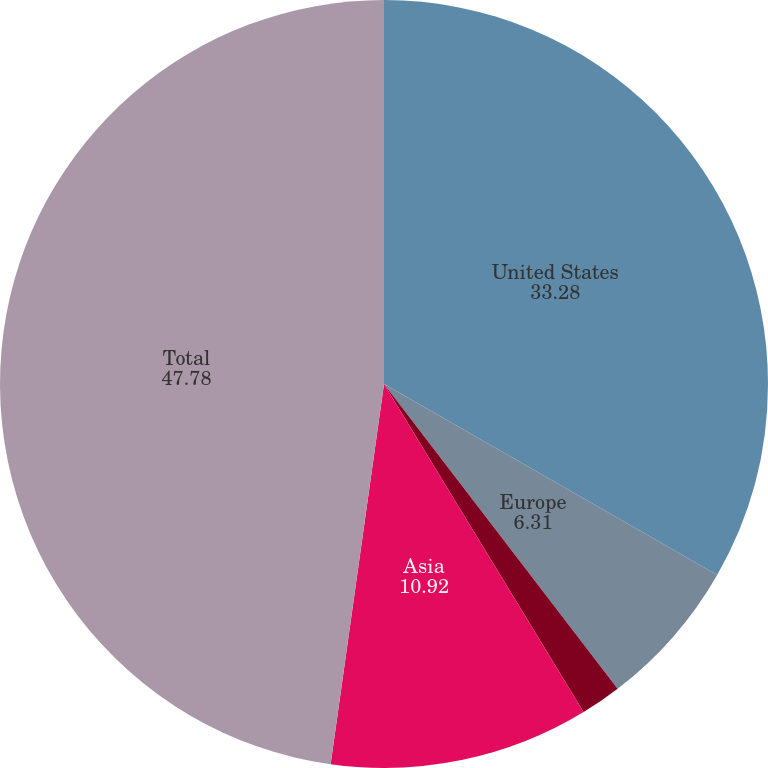Convert chart to OTSL. <chart><loc_0><loc_0><loc_500><loc_500><pie_chart><fcel>United States<fcel>Europe<fcel>Africa<fcel>Asia<fcel>Total<nl><fcel>33.28%<fcel>6.31%<fcel>1.71%<fcel>10.92%<fcel>47.78%<nl></chart> 